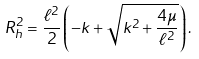<formula> <loc_0><loc_0><loc_500><loc_500>R _ { h } ^ { 2 } = \frac { \ell ^ { 2 } } { 2 } \left ( - k + \sqrt { k ^ { 2 } + \frac { 4 \mu } { \ell ^ { 2 } } } \right ) .</formula> 